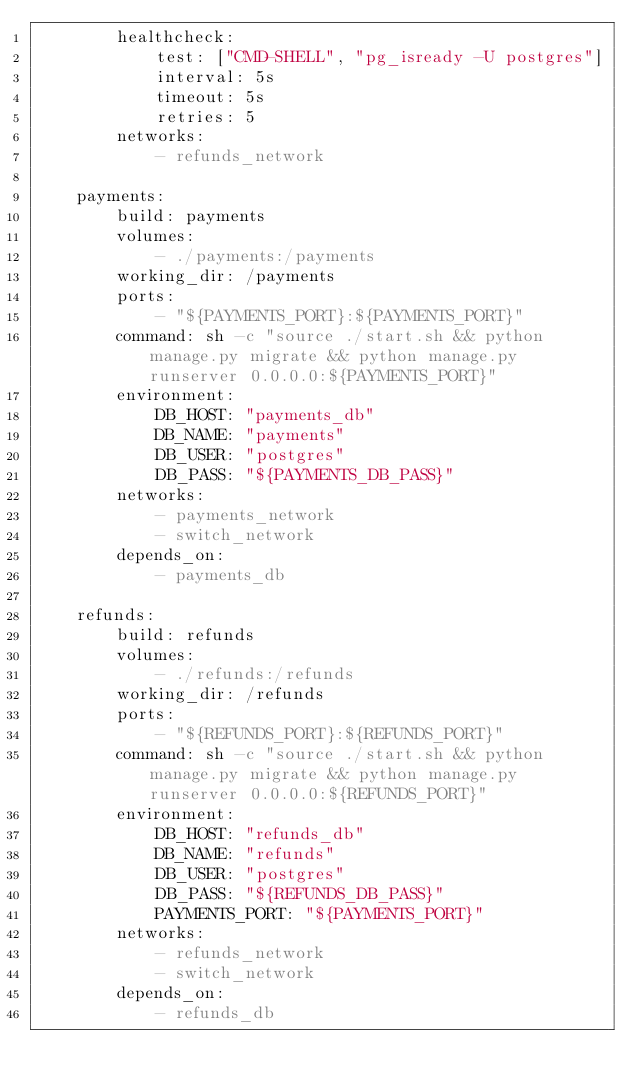<code> <loc_0><loc_0><loc_500><loc_500><_YAML_>        healthcheck:
            test: ["CMD-SHELL", "pg_isready -U postgres"]
            interval: 5s
            timeout: 5s
            retries: 5
        networks:
            - refunds_network

    payments:
        build: payments
        volumes:
            - ./payments:/payments
        working_dir: /payments
        ports:
            - "${PAYMENTS_PORT}:${PAYMENTS_PORT}"
        command: sh -c "source ./start.sh && python manage.py migrate && python manage.py runserver 0.0.0.0:${PAYMENTS_PORT}"
        environment:
            DB_HOST: "payments_db"
            DB_NAME: "payments"
            DB_USER: "postgres"
            DB_PASS: "${PAYMENTS_DB_PASS}"
        networks:
            - payments_network
            - switch_network
        depends_on:
            - payments_db

    refunds:
        build: refunds
        volumes:
            - ./refunds:/refunds
        working_dir: /refunds
        ports:
            - "${REFUNDS_PORT}:${REFUNDS_PORT}"
        command: sh -c "source ./start.sh && python manage.py migrate && python manage.py runserver 0.0.0.0:${REFUNDS_PORT}"
        environment:
            DB_HOST: "refunds_db"
            DB_NAME: "refunds"
            DB_USER: "postgres"
            DB_PASS: "${REFUNDS_DB_PASS}"
            PAYMENTS_PORT: "${PAYMENTS_PORT}"
        networks:
            - refunds_network
            - switch_network
        depends_on:
            - refunds_db
</code> 